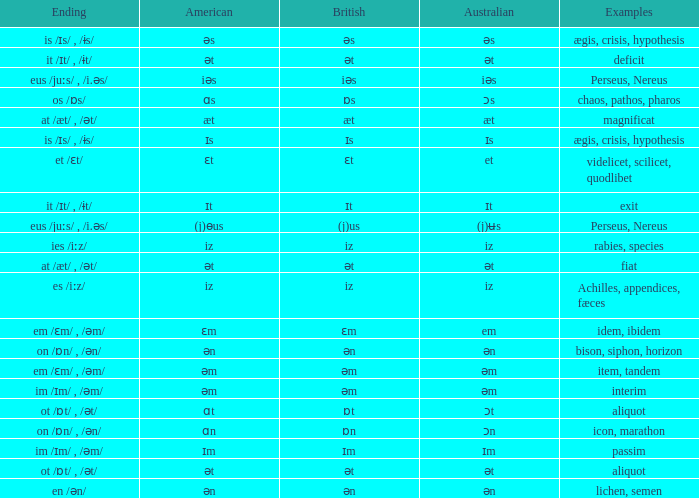Which Examples has Australian of əm? Item, tandem, interim. Can you give me this table as a dict? {'header': ['Ending', 'American', 'British', 'Australian', 'Examples'], 'rows': [['is /ɪs/ , /ɨs/', 'əs', 'əs', 'əs', 'ægis, crisis, hypothesis'], ['it /ɪt/ , /ɨt/', 'ət', 'ət', 'ət', 'deficit'], ['eus /juːs/ , /i.əs/', 'iəs', 'iəs', 'iəs', 'Perseus, Nereus'], ['os /ɒs/', 'ɑs', 'ɒs', 'ɔs', 'chaos, pathos, pharos'], ['at /æt/ , /ət/', 'æt', 'æt', 'æt', 'magnificat'], ['is /ɪs/ , /ɨs/', 'ɪs', 'ɪs', 'ɪs', 'ægis, crisis, hypothesis'], ['et /ɛt/', 'ɛt', 'ɛt', 'et', 'videlicet, scilicet, quodlibet'], ['it /ɪt/ , /ɨt/', 'ɪt', 'ɪt', 'ɪt', 'exit'], ['eus /juːs/ , /i.əs/', '(j)ɵus', '(j)us', '(j)ʉs', 'Perseus, Nereus'], ['ies /iːz/', 'iz', 'iz', 'iz', 'rabies, species'], ['at /æt/ , /ət/', 'ət', 'ət', 'ət', 'fiat'], ['es /iːz/', 'iz', 'iz', 'iz', 'Achilles, appendices, fæces'], ['em /ɛm/ , /əm/', 'ɛm', 'ɛm', 'em', 'idem, ibidem'], ['on /ɒn/ , /ən/', 'ən', 'ən', 'ən', 'bison, siphon, horizon'], ['em /ɛm/ , /əm/', 'əm', 'əm', 'əm', 'item, tandem'], ['im /ɪm/ , /əm/', 'əm', 'əm', 'əm', 'interim'], ['ot /ɒt/ , /ət/', 'ɑt', 'ɒt', 'ɔt', 'aliquot'], ['on /ɒn/ , /ən/', 'ɑn', 'ɒn', 'ɔn', 'icon, marathon'], ['im /ɪm/ , /əm/', 'ɪm', 'ɪm', 'ɪm', 'passim'], ['ot /ɒt/ , /ət/', 'ət', 'ət', 'ət', 'aliquot'], ['en /ən/', 'ən', 'ən', 'ən', 'lichen, semen']]} 